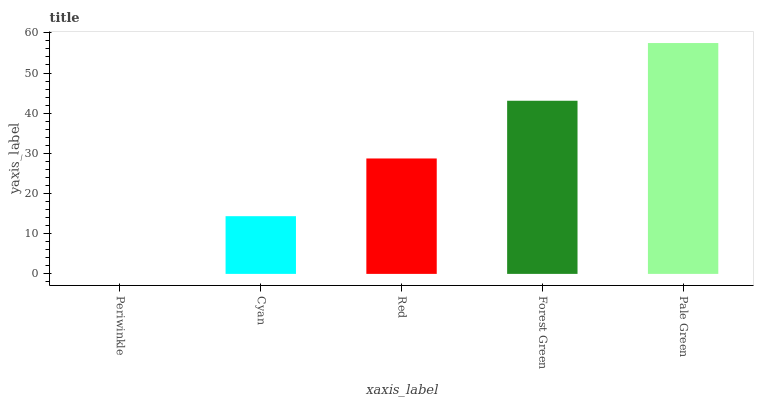Is Cyan the minimum?
Answer yes or no. No. Is Cyan the maximum?
Answer yes or no. No. Is Cyan greater than Periwinkle?
Answer yes or no. Yes. Is Periwinkle less than Cyan?
Answer yes or no. Yes. Is Periwinkle greater than Cyan?
Answer yes or no. No. Is Cyan less than Periwinkle?
Answer yes or no. No. Is Red the high median?
Answer yes or no. Yes. Is Red the low median?
Answer yes or no. Yes. Is Forest Green the high median?
Answer yes or no. No. Is Periwinkle the low median?
Answer yes or no. No. 